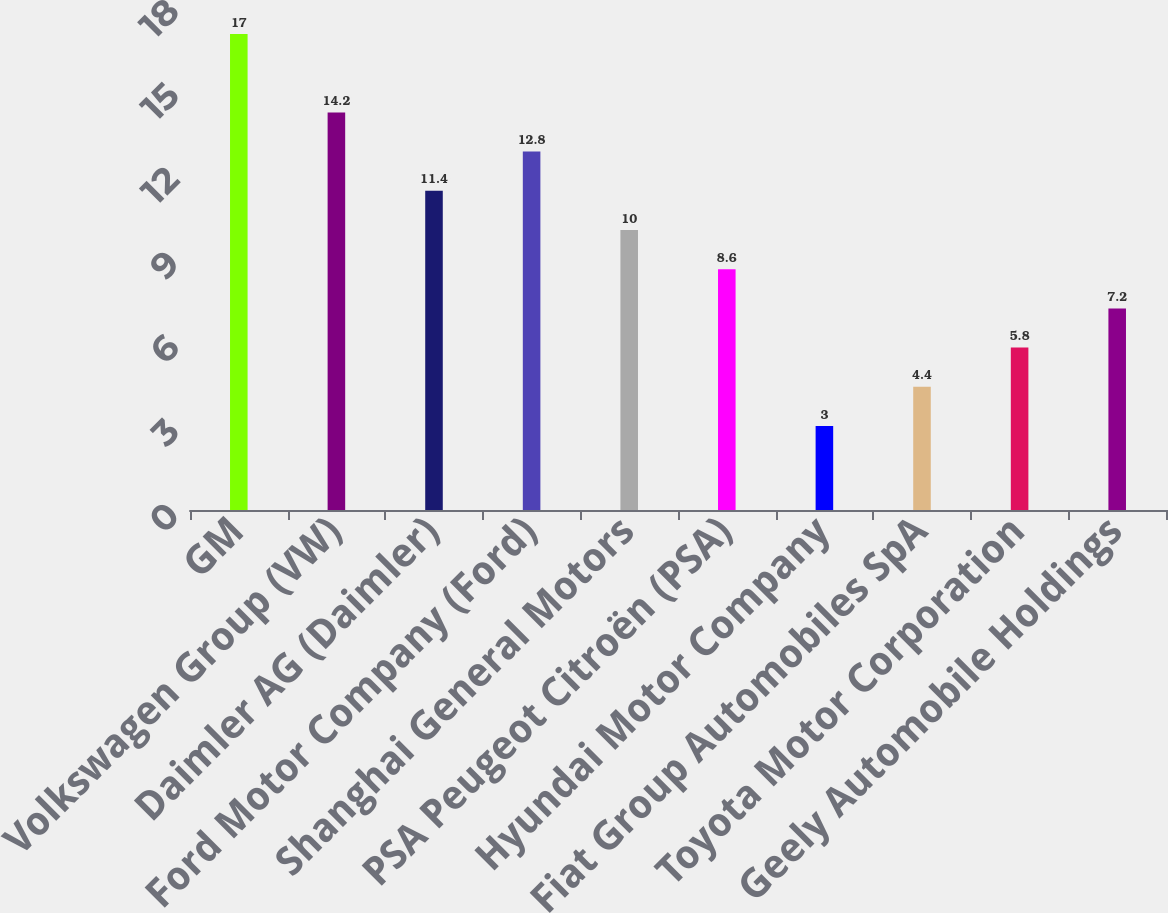<chart> <loc_0><loc_0><loc_500><loc_500><bar_chart><fcel>GM<fcel>Volkswagen Group (VW)<fcel>Daimler AG (Daimler)<fcel>Ford Motor Company (Ford)<fcel>Shanghai General Motors<fcel>PSA Peugeot Citroën (PSA)<fcel>Hyundai Motor Company<fcel>Fiat Group Automobiles SpA<fcel>Toyota Motor Corporation<fcel>Geely Automobile Holdings<nl><fcel>17<fcel>14.2<fcel>11.4<fcel>12.8<fcel>10<fcel>8.6<fcel>3<fcel>4.4<fcel>5.8<fcel>7.2<nl></chart> 